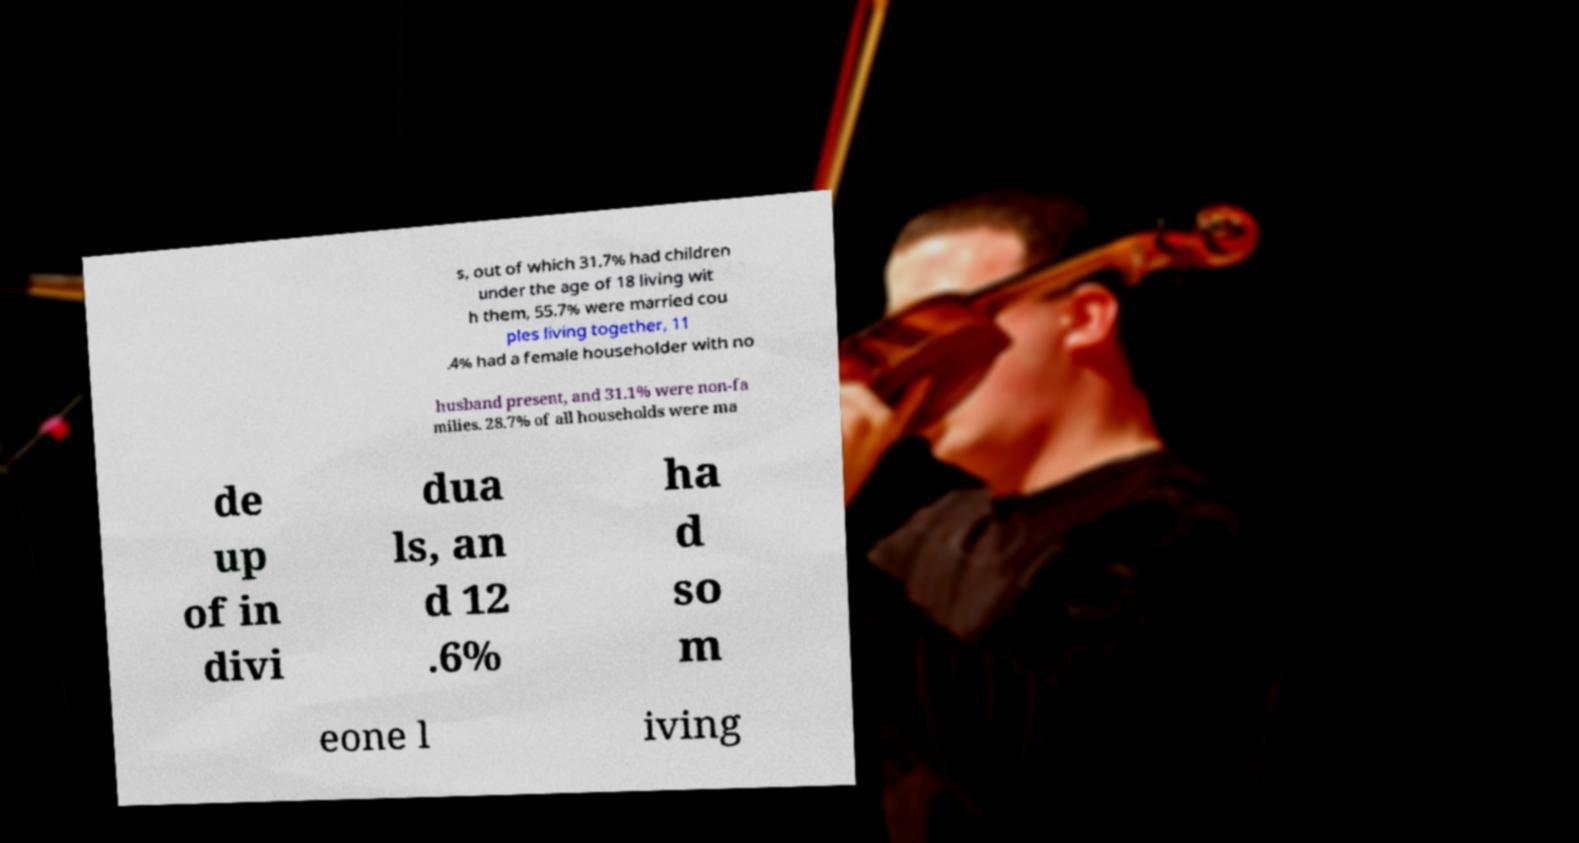Could you extract and type out the text from this image? s, out of which 31.7% had children under the age of 18 living wit h them, 55.7% were married cou ples living together, 11 .4% had a female householder with no husband present, and 31.1% were non-fa milies. 28.7% of all households were ma de up of in divi dua ls, an d 12 .6% ha d so m eone l iving 